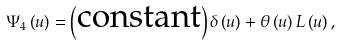Convert formula to latex. <formula><loc_0><loc_0><loc_500><loc_500>\Psi _ { 4 } \left ( u \right ) = \left ( \text {constant} \right ) \delta \left ( u \right ) + \theta \left ( u \right ) L \left ( u \right ) ,</formula> 